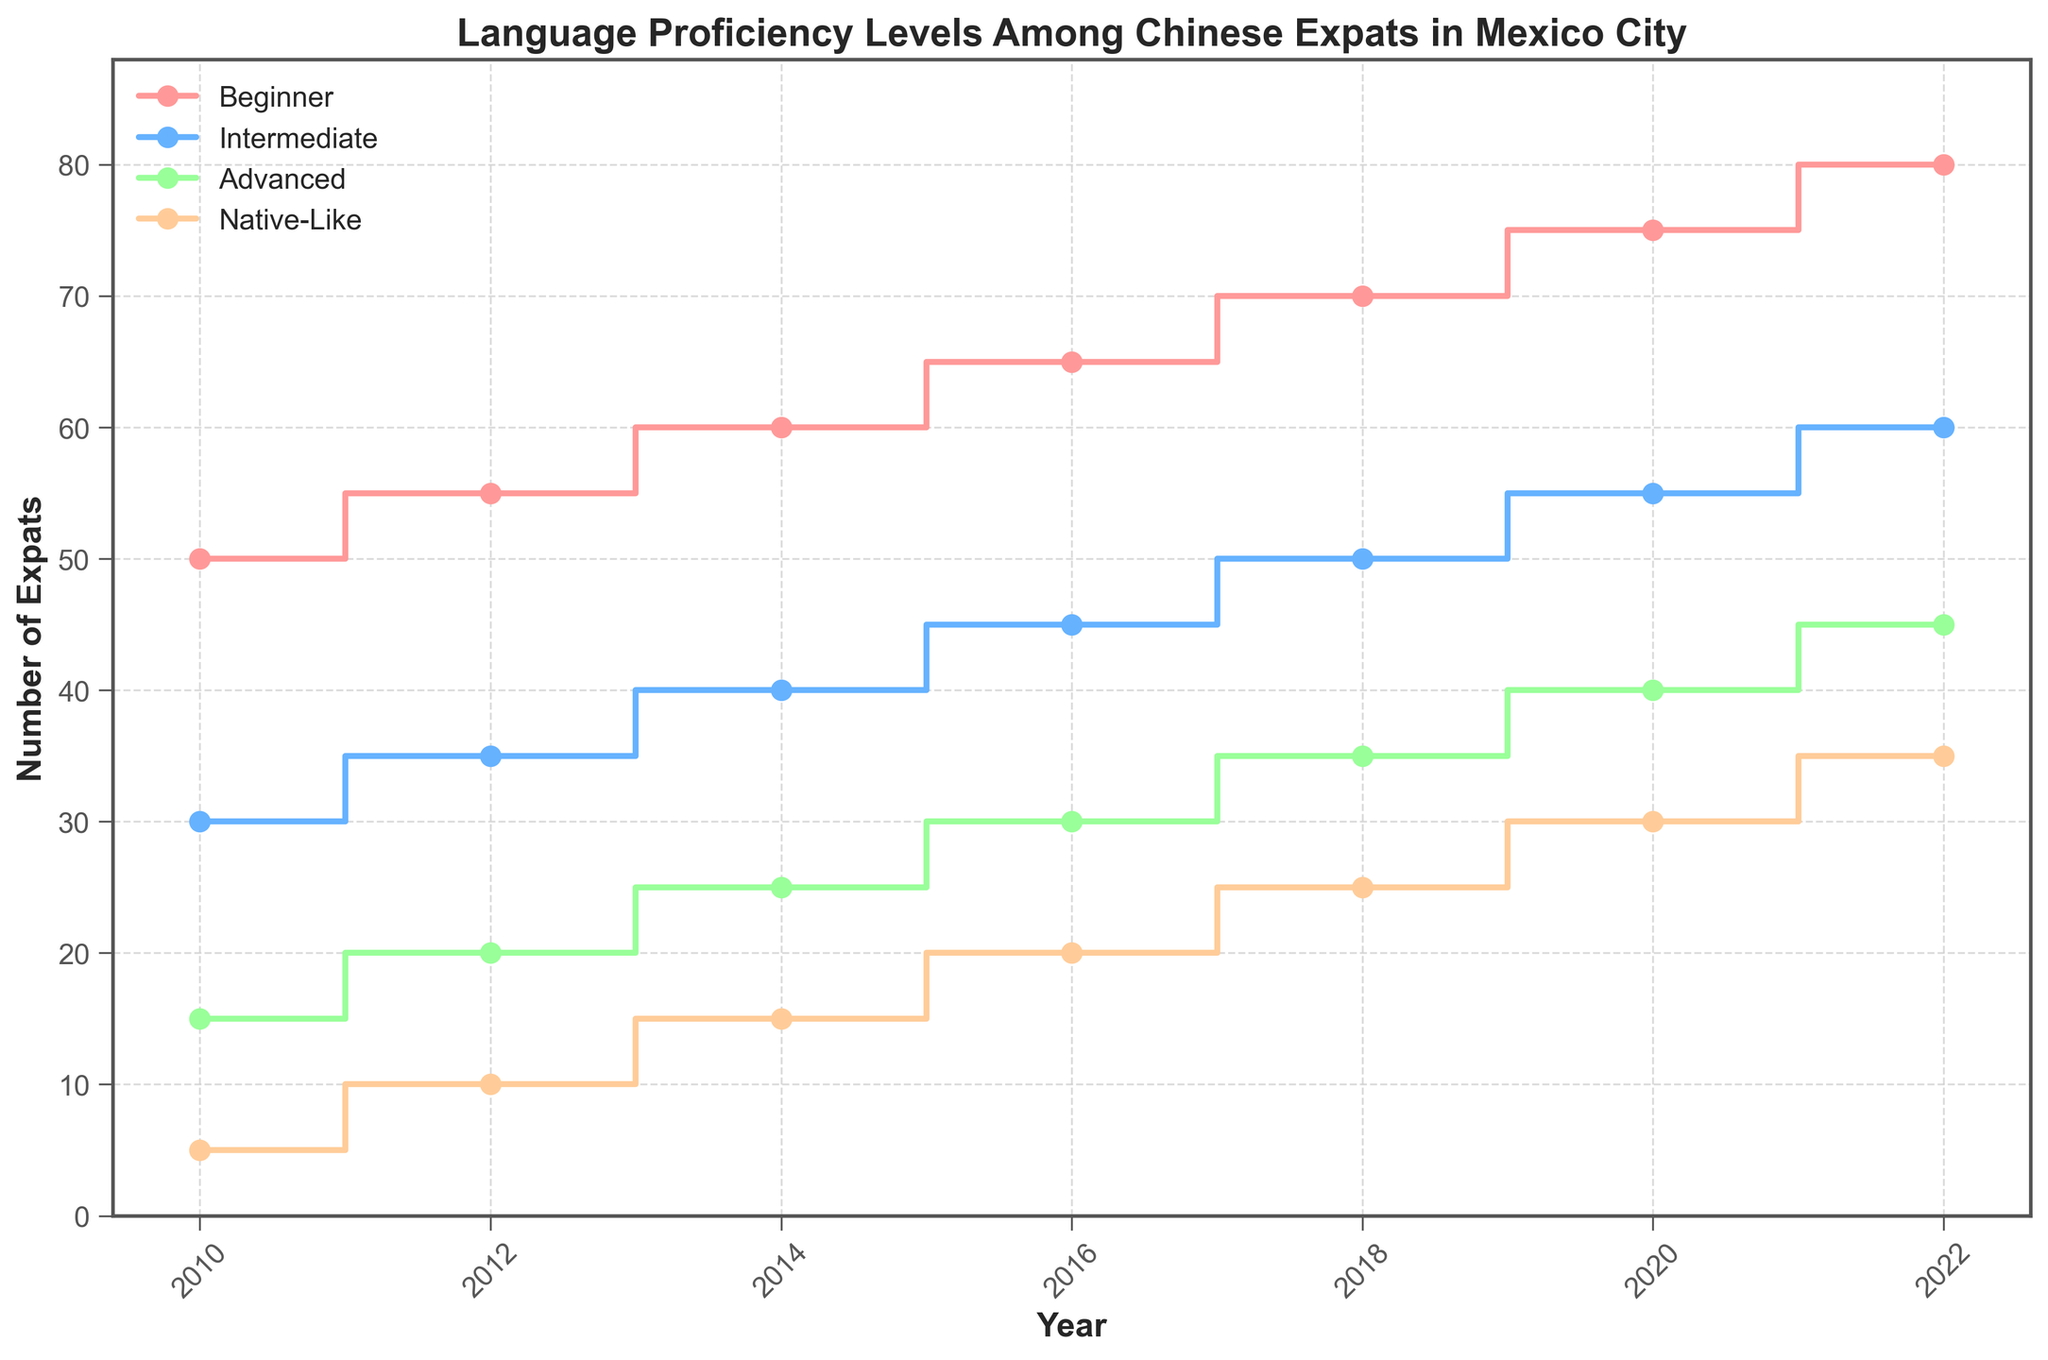What is the title of the plot? The title is at the top of the plot and provides an overall understanding of what the plot is about. The title reads: "Language Proficiency Levels Among Chinese Expats in Mexico City".
Answer: Language Proficiency Levels Among Chinese Expats in Mexico City Which proficiency level had the highest number of expats in 2022? Look for the year 2022 on the x-axis and then check the value of each line. The Beginner level line has the highest value among all proficiency levels in 2022.
Answer: Beginner How many expats were at Intermediate level in 2016? Find the year 2016 on the x-axis and follow it up to the Intermediate line (usually in a specific color). The corresponding y-value gives the number of expats.
Answer: 45 What is the range of expat numbers for the Advanced level over the years? The range can be calculated by subtracting the minimum value from the maximum value of the Advanced level from 2010 to 2022. The values are 15 (2010) and 45 (2022), giving a range of 45 - 15 = 30.
Answer: 30 Compare the number of Native-Like expats in 2014 with 2020. Which year had more Native-Like expats? Find the y-values for Native-Like proficiency in both 2014 and 2020. Compare the values and determine which is higher. 2020 has 30 Native-Like expats while 2014 has 15.
Answer: 2020 Which proficiency level shows the most significant increase from 2010 to 2022? Calculate the difference in expat numbers from 2010 to 2022 for each proficiency level, then compare these differences to find the largest one. The Beginner level increases from 50 in 2010 to 80 in 2022, a difference of 30.
Answer: Beginner How many total expats were recorded in 2018 across all proficiency levels? Add the values of all proficiency levels for the year 2018: Beginner (70), Intermediate (50), Advanced (35), Native-Like (25). Total is 70 + 50 + 35 + 25 = 180.
Answer: 180 What is the average number of Advanced level expats over the years? Sum the number of Advanced level expats for all the years and divide by the number of years (7): (15 + 20 + 25 + 30 + 35 + 40 + 45) / 7 = 30.
Answer: 30 In which year did the Intermediate level surpass 50 expats for the first time? Track the Intermediate level line and note the x-values corresponding to the years when it first crosses 50 y-values. The Intermediate level first surpasses 50 expats in the year 2020.
Answer: 2020 Do the values of Native-Like expats ever exceed those of Advanced expats in the same year? Compare the values of Native-Like and Advanced expats for each year. The Advanced line is consistently higher than the Native-Like line in every year.
Answer: No 